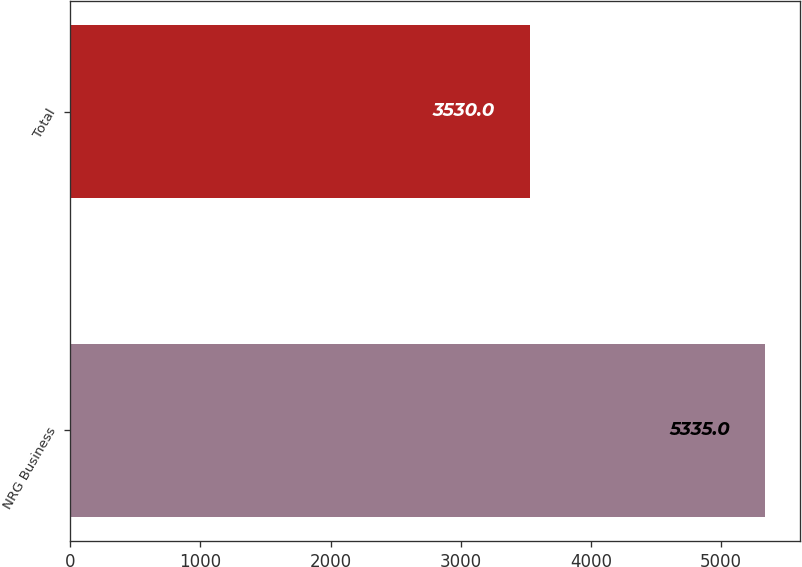Convert chart. <chart><loc_0><loc_0><loc_500><loc_500><bar_chart><fcel>NRG Business<fcel>Total<nl><fcel>5335<fcel>3530<nl></chart> 